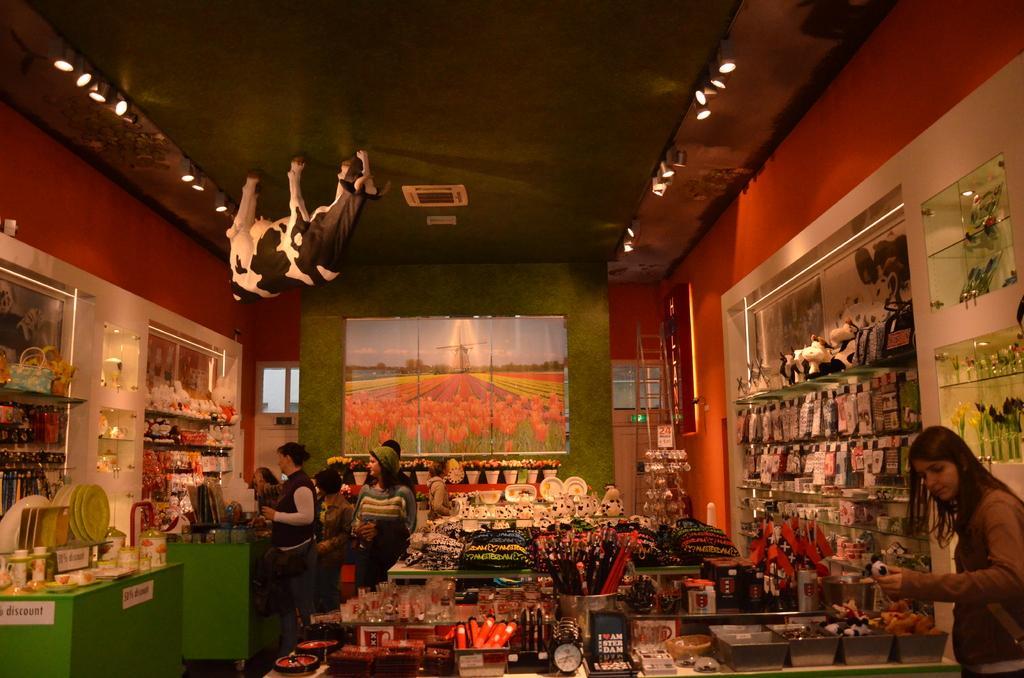Describe this image in one or two sentences. In this image I can see group of people standing and I can see few plates, glasses, bags and few objects on the tables and I can also see few objects in the racks. In the background I can see the colorful object is attached to the wall. 